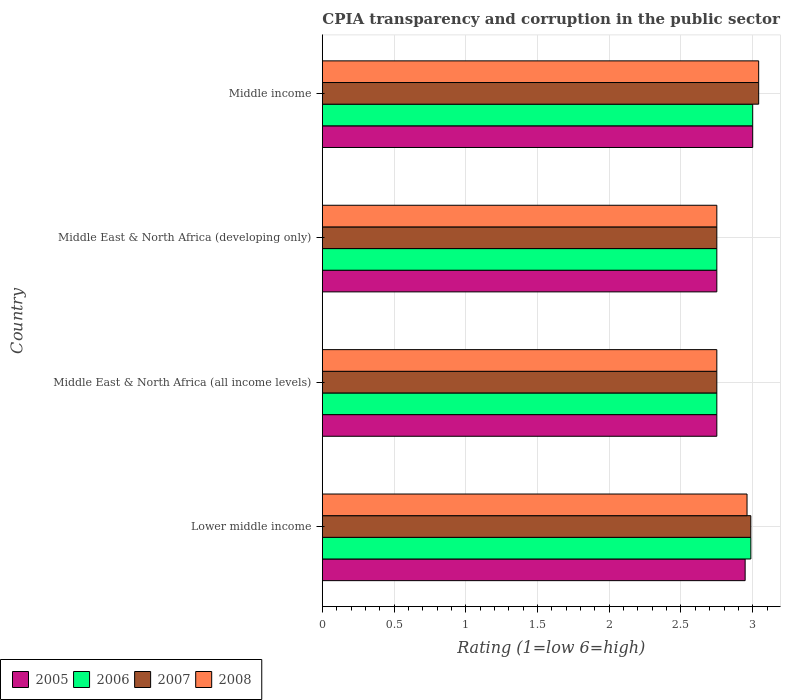How many different coloured bars are there?
Your answer should be very brief. 4. How many groups of bars are there?
Your answer should be very brief. 4. How many bars are there on the 2nd tick from the top?
Offer a very short reply. 4. In how many cases, is the number of bars for a given country not equal to the number of legend labels?
Offer a terse response. 0. What is the CPIA rating in 2007 in Middle East & North Africa (developing only)?
Provide a short and direct response. 2.75. Across all countries, what is the maximum CPIA rating in 2007?
Your answer should be compact. 3.04. Across all countries, what is the minimum CPIA rating in 2005?
Your response must be concise. 2.75. In which country was the CPIA rating in 2008 maximum?
Your response must be concise. Middle income. In which country was the CPIA rating in 2006 minimum?
Make the answer very short. Middle East & North Africa (all income levels). What is the total CPIA rating in 2005 in the graph?
Your response must be concise. 11.45. What is the difference between the CPIA rating in 2006 in Lower middle income and that in Middle East & North Africa (developing only)?
Your answer should be very brief. 0.24. What is the average CPIA rating in 2006 per country?
Your answer should be compact. 2.87. What is the difference between the CPIA rating in 2008 and CPIA rating in 2005 in Middle East & North Africa (all income levels)?
Give a very brief answer. 0. What is the ratio of the CPIA rating in 2007 in Lower middle income to that in Middle East & North Africa (all income levels)?
Offer a terse response. 1.09. Is the CPIA rating in 2007 in Lower middle income less than that in Middle income?
Ensure brevity in your answer.  Yes. What is the difference between the highest and the second highest CPIA rating in 2008?
Offer a terse response. 0.08. What is the difference between the highest and the lowest CPIA rating in 2006?
Ensure brevity in your answer.  0.25. In how many countries, is the CPIA rating in 2007 greater than the average CPIA rating in 2007 taken over all countries?
Your answer should be very brief. 2. Is the sum of the CPIA rating in 2005 in Middle East & North Africa (developing only) and Middle income greater than the maximum CPIA rating in 2006 across all countries?
Offer a very short reply. Yes. Is it the case that in every country, the sum of the CPIA rating in 2007 and CPIA rating in 2008 is greater than the sum of CPIA rating in 2006 and CPIA rating in 2005?
Provide a short and direct response. No. What does the 4th bar from the bottom in Lower middle income represents?
Your answer should be very brief. 2008. Is it the case that in every country, the sum of the CPIA rating in 2008 and CPIA rating in 2006 is greater than the CPIA rating in 2007?
Your answer should be very brief. Yes. How many bars are there?
Your answer should be compact. 16. Are all the bars in the graph horizontal?
Offer a terse response. Yes. How many countries are there in the graph?
Provide a succinct answer. 4. Does the graph contain any zero values?
Your answer should be very brief. No. What is the title of the graph?
Provide a succinct answer. CPIA transparency and corruption in the public sector rating. Does "1987" appear as one of the legend labels in the graph?
Make the answer very short. No. What is the label or title of the X-axis?
Make the answer very short. Rating (1=low 6=high). What is the Rating (1=low 6=high) in 2005 in Lower middle income?
Your answer should be very brief. 2.95. What is the Rating (1=low 6=high) in 2006 in Lower middle income?
Give a very brief answer. 2.99. What is the Rating (1=low 6=high) of 2007 in Lower middle income?
Make the answer very short. 2.99. What is the Rating (1=low 6=high) in 2008 in Lower middle income?
Offer a terse response. 2.96. What is the Rating (1=low 6=high) of 2005 in Middle East & North Africa (all income levels)?
Offer a terse response. 2.75. What is the Rating (1=low 6=high) of 2006 in Middle East & North Africa (all income levels)?
Make the answer very short. 2.75. What is the Rating (1=low 6=high) of 2007 in Middle East & North Africa (all income levels)?
Keep it short and to the point. 2.75. What is the Rating (1=low 6=high) of 2008 in Middle East & North Africa (all income levels)?
Offer a terse response. 2.75. What is the Rating (1=low 6=high) in 2005 in Middle East & North Africa (developing only)?
Give a very brief answer. 2.75. What is the Rating (1=low 6=high) in 2006 in Middle East & North Africa (developing only)?
Keep it short and to the point. 2.75. What is the Rating (1=low 6=high) in 2007 in Middle East & North Africa (developing only)?
Offer a very short reply. 2.75. What is the Rating (1=low 6=high) in 2008 in Middle East & North Africa (developing only)?
Ensure brevity in your answer.  2.75. What is the Rating (1=low 6=high) of 2006 in Middle income?
Your answer should be compact. 3. What is the Rating (1=low 6=high) of 2007 in Middle income?
Make the answer very short. 3.04. What is the Rating (1=low 6=high) of 2008 in Middle income?
Ensure brevity in your answer.  3.04. Across all countries, what is the maximum Rating (1=low 6=high) in 2005?
Your answer should be very brief. 3. Across all countries, what is the maximum Rating (1=low 6=high) in 2006?
Offer a terse response. 3. Across all countries, what is the maximum Rating (1=low 6=high) in 2007?
Keep it short and to the point. 3.04. Across all countries, what is the maximum Rating (1=low 6=high) of 2008?
Keep it short and to the point. 3.04. Across all countries, what is the minimum Rating (1=low 6=high) of 2005?
Offer a terse response. 2.75. Across all countries, what is the minimum Rating (1=low 6=high) of 2006?
Your answer should be compact. 2.75. Across all countries, what is the minimum Rating (1=low 6=high) in 2007?
Offer a terse response. 2.75. Across all countries, what is the minimum Rating (1=low 6=high) in 2008?
Provide a short and direct response. 2.75. What is the total Rating (1=low 6=high) of 2005 in the graph?
Provide a short and direct response. 11.45. What is the total Rating (1=low 6=high) in 2006 in the graph?
Your response must be concise. 11.49. What is the total Rating (1=low 6=high) in 2007 in the graph?
Keep it short and to the point. 11.53. What is the total Rating (1=low 6=high) in 2008 in the graph?
Ensure brevity in your answer.  11.5. What is the difference between the Rating (1=low 6=high) in 2005 in Lower middle income and that in Middle East & North Africa (all income levels)?
Offer a terse response. 0.2. What is the difference between the Rating (1=low 6=high) of 2006 in Lower middle income and that in Middle East & North Africa (all income levels)?
Keep it short and to the point. 0.24. What is the difference between the Rating (1=low 6=high) in 2007 in Lower middle income and that in Middle East & North Africa (all income levels)?
Offer a terse response. 0.24. What is the difference between the Rating (1=low 6=high) in 2008 in Lower middle income and that in Middle East & North Africa (all income levels)?
Keep it short and to the point. 0.21. What is the difference between the Rating (1=low 6=high) in 2005 in Lower middle income and that in Middle East & North Africa (developing only)?
Your answer should be compact. 0.2. What is the difference between the Rating (1=low 6=high) in 2006 in Lower middle income and that in Middle East & North Africa (developing only)?
Make the answer very short. 0.24. What is the difference between the Rating (1=low 6=high) in 2007 in Lower middle income and that in Middle East & North Africa (developing only)?
Your answer should be very brief. 0.24. What is the difference between the Rating (1=low 6=high) of 2008 in Lower middle income and that in Middle East & North Africa (developing only)?
Ensure brevity in your answer.  0.21. What is the difference between the Rating (1=low 6=high) in 2005 in Lower middle income and that in Middle income?
Your answer should be compact. -0.05. What is the difference between the Rating (1=low 6=high) in 2006 in Lower middle income and that in Middle income?
Make the answer very short. -0.01. What is the difference between the Rating (1=low 6=high) of 2007 in Lower middle income and that in Middle income?
Your answer should be compact. -0.05. What is the difference between the Rating (1=low 6=high) in 2008 in Lower middle income and that in Middle income?
Your answer should be compact. -0.08. What is the difference between the Rating (1=low 6=high) in 2007 in Middle East & North Africa (all income levels) and that in Middle East & North Africa (developing only)?
Make the answer very short. 0. What is the difference between the Rating (1=low 6=high) in 2005 in Middle East & North Africa (all income levels) and that in Middle income?
Your answer should be compact. -0.25. What is the difference between the Rating (1=low 6=high) in 2006 in Middle East & North Africa (all income levels) and that in Middle income?
Your answer should be compact. -0.25. What is the difference between the Rating (1=low 6=high) in 2007 in Middle East & North Africa (all income levels) and that in Middle income?
Your answer should be compact. -0.29. What is the difference between the Rating (1=low 6=high) of 2008 in Middle East & North Africa (all income levels) and that in Middle income?
Keep it short and to the point. -0.29. What is the difference between the Rating (1=low 6=high) of 2006 in Middle East & North Africa (developing only) and that in Middle income?
Your response must be concise. -0.25. What is the difference between the Rating (1=low 6=high) in 2007 in Middle East & North Africa (developing only) and that in Middle income?
Your answer should be compact. -0.29. What is the difference between the Rating (1=low 6=high) of 2008 in Middle East & North Africa (developing only) and that in Middle income?
Your response must be concise. -0.29. What is the difference between the Rating (1=low 6=high) in 2005 in Lower middle income and the Rating (1=low 6=high) in 2006 in Middle East & North Africa (all income levels)?
Give a very brief answer. 0.2. What is the difference between the Rating (1=low 6=high) in 2005 in Lower middle income and the Rating (1=low 6=high) in 2007 in Middle East & North Africa (all income levels)?
Give a very brief answer. 0.2. What is the difference between the Rating (1=low 6=high) in 2005 in Lower middle income and the Rating (1=low 6=high) in 2008 in Middle East & North Africa (all income levels)?
Keep it short and to the point. 0.2. What is the difference between the Rating (1=low 6=high) in 2006 in Lower middle income and the Rating (1=low 6=high) in 2007 in Middle East & North Africa (all income levels)?
Your answer should be compact. 0.24. What is the difference between the Rating (1=low 6=high) of 2006 in Lower middle income and the Rating (1=low 6=high) of 2008 in Middle East & North Africa (all income levels)?
Provide a short and direct response. 0.24. What is the difference between the Rating (1=low 6=high) of 2007 in Lower middle income and the Rating (1=low 6=high) of 2008 in Middle East & North Africa (all income levels)?
Ensure brevity in your answer.  0.24. What is the difference between the Rating (1=low 6=high) in 2005 in Lower middle income and the Rating (1=low 6=high) in 2006 in Middle East & North Africa (developing only)?
Give a very brief answer. 0.2. What is the difference between the Rating (1=low 6=high) in 2005 in Lower middle income and the Rating (1=low 6=high) in 2007 in Middle East & North Africa (developing only)?
Make the answer very short. 0.2. What is the difference between the Rating (1=low 6=high) of 2005 in Lower middle income and the Rating (1=low 6=high) of 2008 in Middle East & North Africa (developing only)?
Make the answer very short. 0.2. What is the difference between the Rating (1=low 6=high) in 2006 in Lower middle income and the Rating (1=low 6=high) in 2007 in Middle East & North Africa (developing only)?
Your answer should be compact. 0.24. What is the difference between the Rating (1=low 6=high) of 2006 in Lower middle income and the Rating (1=low 6=high) of 2008 in Middle East & North Africa (developing only)?
Your answer should be compact. 0.24. What is the difference between the Rating (1=low 6=high) of 2007 in Lower middle income and the Rating (1=low 6=high) of 2008 in Middle East & North Africa (developing only)?
Ensure brevity in your answer.  0.24. What is the difference between the Rating (1=low 6=high) of 2005 in Lower middle income and the Rating (1=low 6=high) of 2006 in Middle income?
Your answer should be compact. -0.05. What is the difference between the Rating (1=low 6=high) of 2005 in Lower middle income and the Rating (1=low 6=high) of 2007 in Middle income?
Provide a short and direct response. -0.09. What is the difference between the Rating (1=low 6=high) in 2005 in Lower middle income and the Rating (1=low 6=high) in 2008 in Middle income?
Offer a terse response. -0.09. What is the difference between the Rating (1=low 6=high) of 2006 in Lower middle income and the Rating (1=low 6=high) of 2007 in Middle income?
Your answer should be compact. -0.05. What is the difference between the Rating (1=low 6=high) of 2006 in Lower middle income and the Rating (1=low 6=high) of 2008 in Middle income?
Ensure brevity in your answer.  -0.05. What is the difference between the Rating (1=low 6=high) in 2007 in Lower middle income and the Rating (1=low 6=high) in 2008 in Middle income?
Ensure brevity in your answer.  -0.05. What is the difference between the Rating (1=low 6=high) in 2005 in Middle East & North Africa (all income levels) and the Rating (1=low 6=high) in 2007 in Middle East & North Africa (developing only)?
Offer a very short reply. 0. What is the difference between the Rating (1=low 6=high) in 2005 in Middle East & North Africa (all income levels) and the Rating (1=low 6=high) in 2008 in Middle East & North Africa (developing only)?
Your response must be concise. 0. What is the difference between the Rating (1=low 6=high) of 2005 in Middle East & North Africa (all income levels) and the Rating (1=low 6=high) of 2006 in Middle income?
Give a very brief answer. -0.25. What is the difference between the Rating (1=low 6=high) of 2005 in Middle East & North Africa (all income levels) and the Rating (1=low 6=high) of 2007 in Middle income?
Make the answer very short. -0.29. What is the difference between the Rating (1=low 6=high) of 2005 in Middle East & North Africa (all income levels) and the Rating (1=low 6=high) of 2008 in Middle income?
Ensure brevity in your answer.  -0.29. What is the difference between the Rating (1=low 6=high) of 2006 in Middle East & North Africa (all income levels) and the Rating (1=low 6=high) of 2007 in Middle income?
Offer a very short reply. -0.29. What is the difference between the Rating (1=low 6=high) in 2006 in Middle East & North Africa (all income levels) and the Rating (1=low 6=high) in 2008 in Middle income?
Give a very brief answer. -0.29. What is the difference between the Rating (1=low 6=high) of 2007 in Middle East & North Africa (all income levels) and the Rating (1=low 6=high) of 2008 in Middle income?
Provide a short and direct response. -0.29. What is the difference between the Rating (1=low 6=high) of 2005 in Middle East & North Africa (developing only) and the Rating (1=low 6=high) of 2007 in Middle income?
Keep it short and to the point. -0.29. What is the difference between the Rating (1=low 6=high) of 2005 in Middle East & North Africa (developing only) and the Rating (1=low 6=high) of 2008 in Middle income?
Make the answer very short. -0.29. What is the difference between the Rating (1=low 6=high) of 2006 in Middle East & North Africa (developing only) and the Rating (1=low 6=high) of 2007 in Middle income?
Give a very brief answer. -0.29. What is the difference between the Rating (1=low 6=high) in 2006 in Middle East & North Africa (developing only) and the Rating (1=low 6=high) in 2008 in Middle income?
Offer a very short reply. -0.29. What is the difference between the Rating (1=low 6=high) in 2007 in Middle East & North Africa (developing only) and the Rating (1=low 6=high) in 2008 in Middle income?
Offer a very short reply. -0.29. What is the average Rating (1=low 6=high) of 2005 per country?
Make the answer very short. 2.86. What is the average Rating (1=low 6=high) of 2006 per country?
Keep it short and to the point. 2.87. What is the average Rating (1=low 6=high) in 2007 per country?
Offer a terse response. 2.88. What is the average Rating (1=low 6=high) in 2008 per country?
Your answer should be compact. 2.88. What is the difference between the Rating (1=low 6=high) of 2005 and Rating (1=low 6=high) of 2006 in Lower middle income?
Keep it short and to the point. -0.04. What is the difference between the Rating (1=low 6=high) of 2005 and Rating (1=low 6=high) of 2007 in Lower middle income?
Offer a terse response. -0.04. What is the difference between the Rating (1=low 6=high) of 2005 and Rating (1=low 6=high) of 2008 in Lower middle income?
Your response must be concise. -0.01. What is the difference between the Rating (1=low 6=high) in 2006 and Rating (1=low 6=high) in 2008 in Lower middle income?
Keep it short and to the point. 0.03. What is the difference between the Rating (1=low 6=high) in 2007 and Rating (1=low 6=high) in 2008 in Lower middle income?
Keep it short and to the point. 0.03. What is the difference between the Rating (1=low 6=high) in 2005 and Rating (1=low 6=high) in 2006 in Middle East & North Africa (all income levels)?
Offer a terse response. 0. What is the difference between the Rating (1=low 6=high) in 2005 and Rating (1=low 6=high) in 2008 in Middle East & North Africa (all income levels)?
Your response must be concise. 0. What is the difference between the Rating (1=low 6=high) of 2006 and Rating (1=low 6=high) of 2008 in Middle East & North Africa (all income levels)?
Ensure brevity in your answer.  0. What is the difference between the Rating (1=low 6=high) of 2005 and Rating (1=low 6=high) of 2008 in Middle East & North Africa (developing only)?
Keep it short and to the point. 0. What is the difference between the Rating (1=low 6=high) in 2006 and Rating (1=low 6=high) in 2007 in Middle East & North Africa (developing only)?
Provide a short and direct response. 0. What is the difference between the Rating (1=low 6=high) of 2006 and Rating (1=low 6=high) of 2008 in Middle East & North Africa (developing only)?
Your response must be concise. 0. What is the difference between the Rating (1=low 6=high) of 2007 and Rating (1=low 6=high) of 2008 in Middle East & North Africa (developing only)?
Give a very brief answer. 0. What is the difference between the Rating (1=low 6=high) in 2005 and Rating (1=low 6=high) in 2006 in Middle income?
Your response must be concise. 0. What is the difference between the Rating (1=low 6=high) in 2005 and Rating (1=low 6=high) in 2007 in Middle income?
Provide a short and direct response. -0.04. What is the difference between the Rating (1=low 6=high) of 2005 and Rating (1=low 6=high) of 2008 in Middle income?
Ensure brevity in your answer.  -0.04. What is the difference between the Rating (1=low 6=high) in 2006 and Rating (1=low 6=high) in 2007 in Middle income?
Provide a short and direct response. -0.04. What is the difference between the Rating (1=low 6=high) of 2006 and Rating (1=low 6=high) of 2008 in Middle income?
Your answer should be compact. -0.04. What is the difference between the Rating (1=low 6=high) of 2007 and Rating (1=low 6=high) of 2008 in Middle income?
Give a very brief answer. 0. What is the ratio of the Rating (1=low 6=high) in 2005 in Lower middle income to that in Middle East & North Africa (all income levels)?
Provide a succinct answer. 1.07. What is the ratio of the Rating (1=low 6=high) of 2006 in Lower middle income to that in Middle East & North Africa (all income levels)?
Keep it short and to the point. 1.09. What is the ratio of the Rating (1=low 6=high) in 2007 in Lower middle income to that in Middle East & North Africa (all income levels)?
Give a very brief answer. 1.09. What is the ratio of the Rating (1=low 6=high) in 2008 in Lower middle income to that in Middle East & North Africa (all income levels)?
Offer a terse response. 1.08. What is the ratio of the Rating (1=low 6=high) in 2005 in Lower middle income to that in Middle East & North Africa (developing only)?
Give a very brief answer. 1.07. What is the ratio of the Rating (1=low 6=high) of 2006 in Lower middle income to that in Middle East & North Africa (developing only)?
Offer a very short reply. 1.09. What is the ratio of the Rating (1=low 6=high) in 2007 in Lower middle income to that in Middle East & North Africa (developing only)?
Give a very brief answer. 1.09. What is the ratio of the Rating (1=low 6=high) in 2008 in Lower middle income to that in Middle East & North Africa (developing only)?
Your answer should be compact. 1.08. What is the ratio of the Rating (1=low 6=high) of 2005 in Lower middle income to that in Middle income?
Provide a succinct answer. 0.98. What is the ratio of the Rating (1=low 6=high) of 2006 in Lower middle income to that in Middle income?
Your answer should be compact. 1. What is the ratio of the Rating (1=low 6=high) of 2008 in Lower middle income to that in Middle income?
Offer a terse response. 0.97. What is the ratio of the Rating (1=low 6=high) of 2006 in Middle East & North Africa (all income levels) to that in Middle East & North Africa (developing only)?
Make the answer very short. 1. What is the ratio of the Rating (1=low 6=high) of 2007 in Middle East & North Africa (all income levels) to that in Middle East & North Africa (developing only)?
Give a very brief answer. 1. What is the ratio of the Rating (1=low 6=high) of 2008 in Middle East & North Africa (all income levels) to that in Middle East & North Africa (developing only)?
Give a very brief answer. 1. What is the ratio of the Rating (1=low 6=high) in 2007 in Middle East & North Africa (all income levels) to that in Middle income?
Provide a succinct answer. 0.9. What is the ratio of the Rating (1=low 6=high) in 2008 in Middle East & North Africa (all income levels) to that in Middle income?
Your answer should be compact. 0.9. What is the ratio of the Rating (1=low 6=high) of 2006 in Middle East & North Africa (developing only) to that in Middle income?
Your answer should be very brief. 0.92. What is the ratio of the Rating (1=low 6=high) of 2007 in Middle East & North Africa (developing only) to that in Middle income?
Your response must be concise. 0.9. What is the ratio of the Rating (1=low 6=high) of 2008 in Middle East & North Africa (developing only) to that in Middle income?
Give a very brief answer. 0.9. What is the difference between the highest and the second highest Rating (1=low 6=high) of 2005?
Your response must be concise. 0.05. What is the difference between the highest and the second highest Rating (1=low 6=high) of 2006?
Ensure brevity in your answer.  0.01. What is the difference between the highest and the second highest Rating (1=low 6=high) in 2007?
Your response must be concise. 0.05. What is the difference between the highest and the second highest Rating (1=low 6=high) of 2008?
Provide a short and direct response. 0.08. What is the difference between the highest and the lowest Rating (1=low 6=high) in 2005?
Your answer should be very brief. 0.25. What is the difference between the highest and the lowest Rating (1=low 6=high) of 2006?
Make the answer very short. 0.25. What is the difference between the highest and the lowest Rating (1=low 6=high) of 2007?
Offer a very short reply. 0.29. What is the difference between the highest and the lowest Rating (1=low 6=high) of 2008?
Provide a succinct answer. 0.29. 